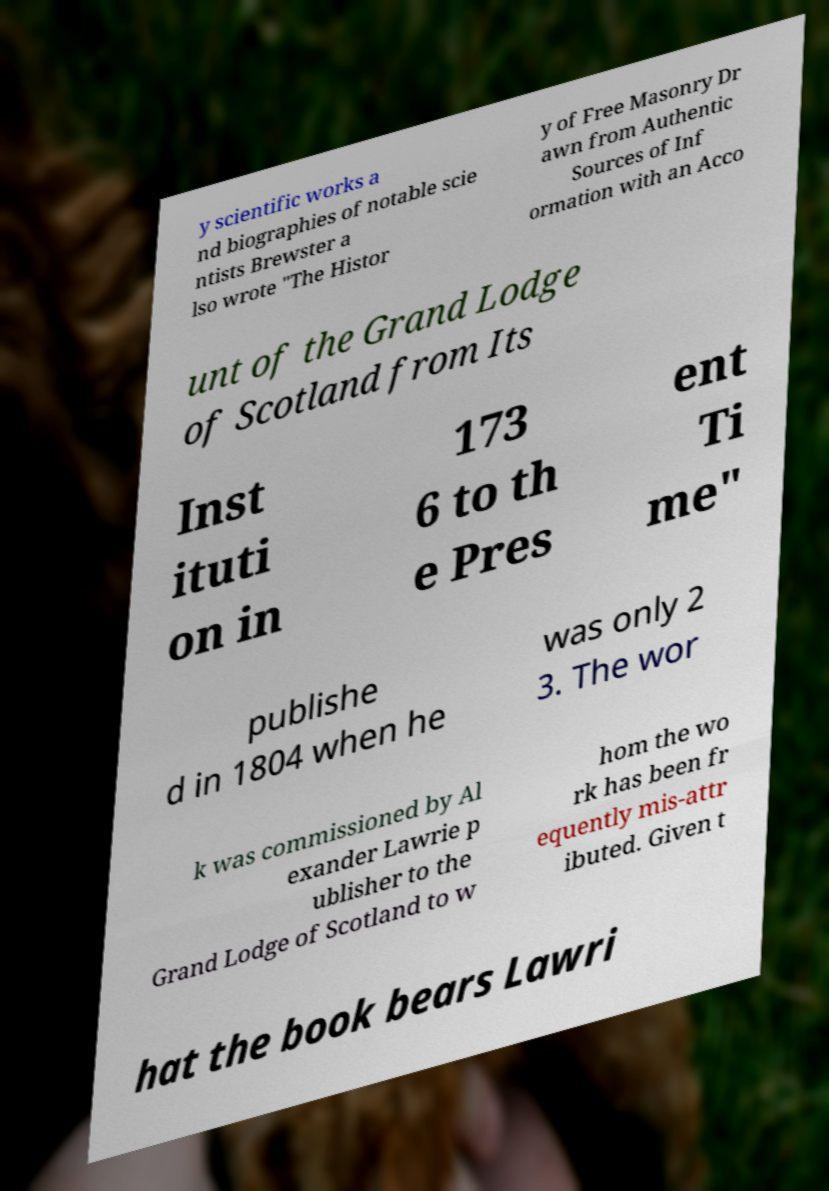What messages or text are displayed in this image? I need them in a readable, typed format. y scientific works a nd biographies of notable scie ntists Brewster a lso wrote "The Histor y of Free Masonry Dr awn from Authentic Sources of Inf ormation with an Acco unt of the Grand Lodge of Scotland from Its Inst ituti on in 173 6 to th e Pres ent Ti me" publishe d in 1804 when he was only 2 3. The wor k was commissioned by Al exander Lawrie p ublisher to the Grand Lodge of Scotland to w hom the wo rk has been fr equently mis-attr ibuted. Given t hat the book bears Lawri 